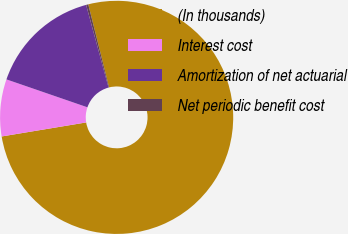Convert chart. <chart><loc_0><loc_0><loc_500><loc_500><pie_chart><fcel>(In thousands)<fcel>Interest cost<fcel>Amortization of net actuarial<fcel>Net periodic benefit cost<nl><fcel>76.29%<fcel>7.9%<fcel>15.5%<fcel>0.3%<nl></chart> 